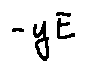Convert formula to latex. <formula><loc_0><loc_0><loc_500><loc_500>- y E</formula> 